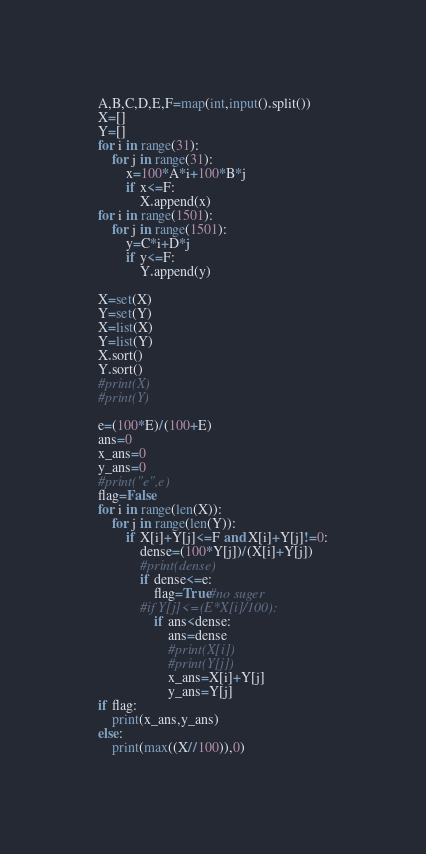<code> <loc_0><loc_0><loc_500><loc_500><_Python_>A,B,C,D,E,F=map(int,input().split())
X=[]
Y=[]
for i in range(31):
    for j in range(31):
        x=100*A*i+100*B*j
        if x<=F:
            X.append(x)
for i in range(1501):
    for j in range(1501):
        y=C*i+D*j
        if y<=F:
            Y.append(y)

X=set(X)
Y=set(Y)
X=list(X)
Y=list(Y)
X.sort()
Y.sort()
#print(X)
#print(Y)

e=(100*E)/(100+E)
ans=0
x_ans=0
y_ans=0
#print("e",e)
flag=False
for i in range(len(X)):
    for j in range(len(Y)):
        if X[i]+Y[j]<=F and X[i]+Y[j]!=0:
            dense=(100*Y[j])/(X[i]+Y[j])
            #print(dense)
            if dense<=e:
                flag=True#no suger
            #if Y[j]<=(E*X[i]/100):
                if ans<dense:
                    ans=dense
                    #print(X[i])
                    #print(Y[j])
                    x_ans=X[i]+Y[j]
                    y_ans=Y[j]
if flag:
    print(x_ans,y_ans)
else:
    print(max((X//100)),0)
</code> 